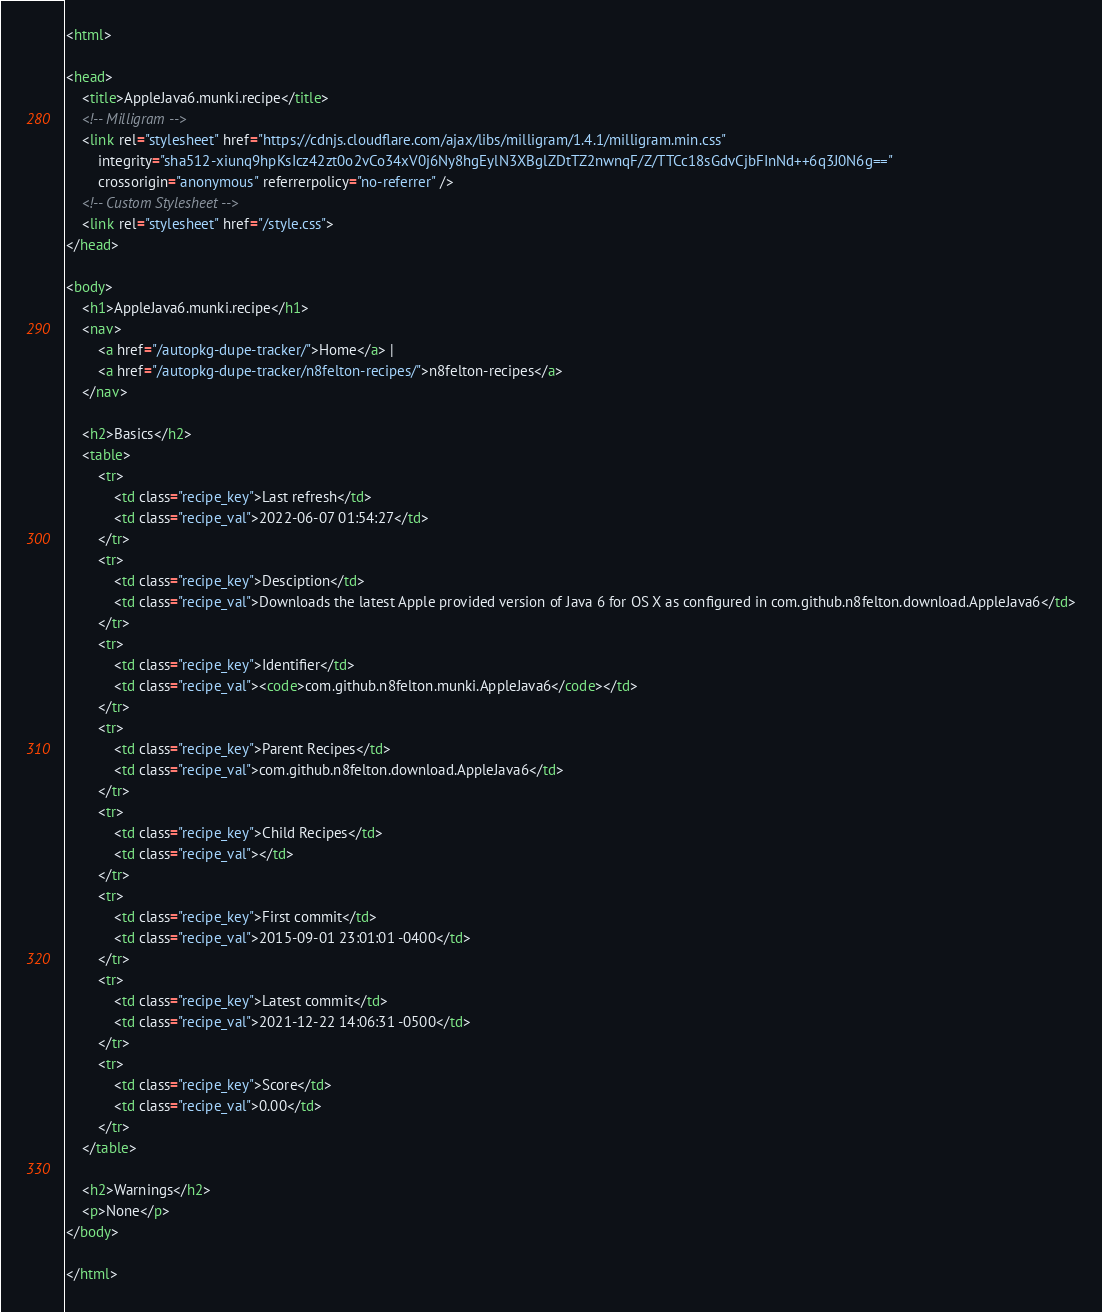<code> <loc_0><loc_0><loc_500><loc_500><_HTML_><html>

<head>
    <title>AppleJava6.munki.recipe</title>
    <!-- Milligram -->
    <link rel="stylesheet" href="https://cdnjs.cloudflare.com/ajax/libs/milligram/1.4.1/milligram.min.css"
        integrity="sha512-xiunq9hpKsIcz42zt0o2vCo34xV0j6Ny8hgEylN3XBglZDtTZ2nwnqF/Z/TTCc18sGdvCjbFInNd++6q3J0N6g=="
        crossorigin="anonymous" referrerpolicy="no-referrer" />
    <!-- Custom Stylesheet -->
    <link rel="stylesheet" href="/style.css">
</head>

<body>
    <h1>AppleJava6.munki.recipe</h1>
    <nav>
        <a href="/autopkg-dupe-tracker/">Home</a> |
        <a href="/autopkg-dupe-tracker/n8felton-recipes/">n8felton-recipes</a>
    </nav>

    <h2>Basics</h2>
    <table>
        <tr>
            <td class="recipe_key">Last refresh</td>
            <td class="recipe_val">2022-06-07 01:54:27</td>
        </tr>
        <tr>
            <td class="recipe_key">Desciption</td>
            <td class="recipe_val">Downloads the latest Apple provided version of Java 6 for OS X as configured in com.github.n8felton.download.AppleJava6</td>
        </tr>
        <tr>
            <td class="recipe_key">Identifier</td>
            <td class="recipe_val"><code>com.github.n8felton.munki.AppleJava6</code></td>
        </tr>
        <tr>
            <td class="recipe_key">Parent Recipes</td>
            <td class="recipe_val">com.github.n8felton.download.AppleJava6</td>
        </tr>
        <tr>
            <td class="recipe_key">Child Recipes</td>
            <td class="recipe_val"></td>
        </tr>
        <tr>
            <td class="recipe_key">First commit</td>
            <td class="recipe_val">2015-09-01 23:01:01 -0400</td>
        </tr>
        <tr>
            <td class="recipe_key">Latest commit</td>
            <td class="recipe_val">2021-12-22 14:06:31 -0500</td>
        </tr>
        <tr>
            <td class="recipe_key">Score</td>
            <td class="recipe_val">0.00</td>
        </tr>
    </table>

    <h2>Warnings</h2>
    <p>None</p>
</body>

</html>
</code> 